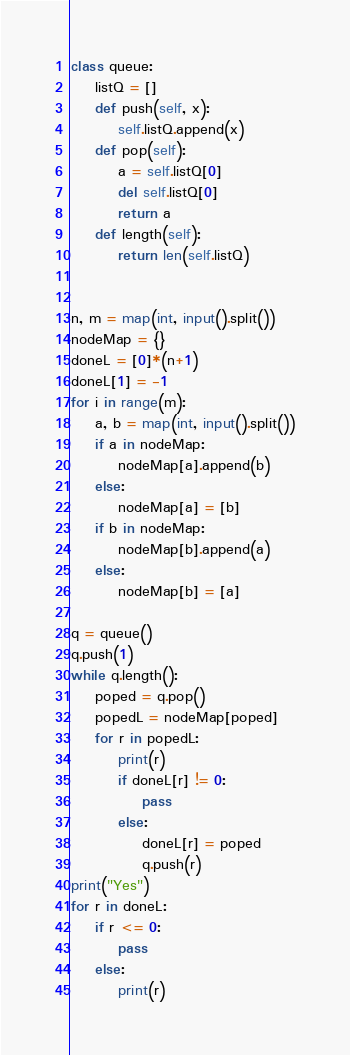<code> <loc_0><loc_0><loc_500><loc_500><_Python_>class queue:
    listQ = []
    def push(self, x):
        self.listQ.append(x)
    def pop(self):
        a = self.listQ[0]
        del self.listQ[0]
        return a
    def length(self):
        return len(self.listQ)


n, m = map(int, input().split())
nodeMap = {}
doneL = [0]*(n+1)
doneL[1] = -1
for i in range(m):
    a, b = map(int, input().split())
    if a in nodeMap:
        nodeMap[a].append(b)
    else:
        nodeMap[a] = [b]
    if b in nodeMap:
        nodeMap[b].append(a)
    else:
        nodeMap[b] = [a]

q = queue()
q.push(1)
while q.length():
    poped = q.pop()
    popedL = nodeMap[poped]
    for r in popedL:
        print(r)
        if doneL[r] != 0:
            pass
        else:
            doneL[r] = poped
            q.push(r)
print("Yes")
for r in doneL:
    if r <= 0:
        pass
    else:
        print(r)</code> 